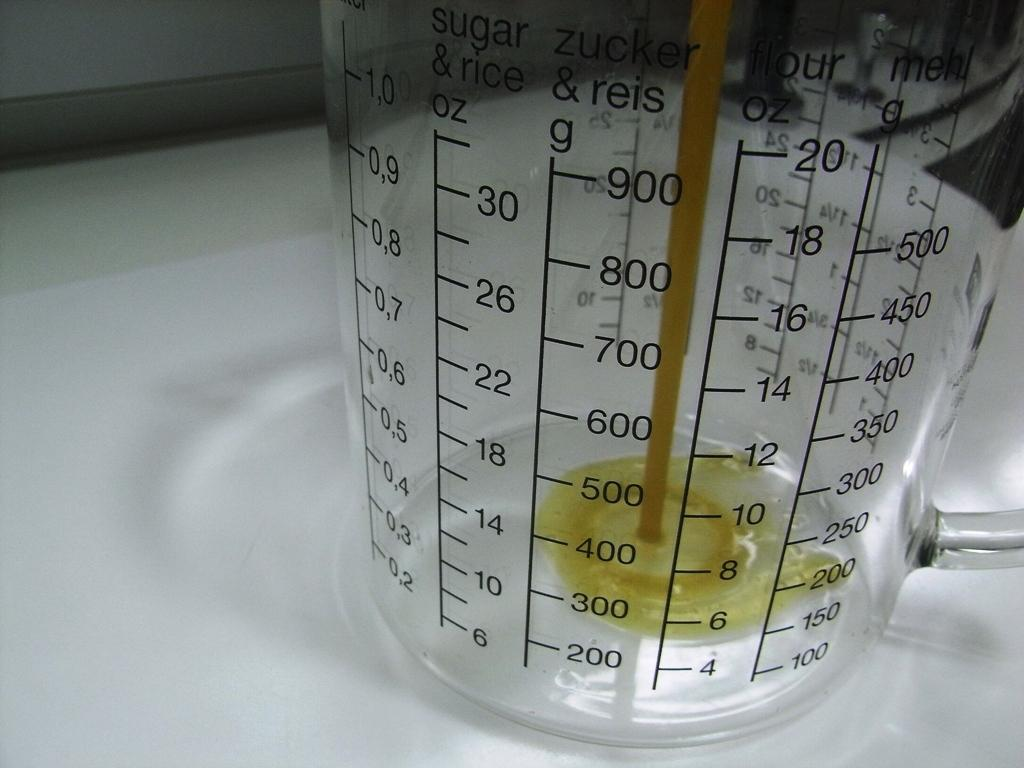<image>
Share a concise interpretation of the image provided. a glass beaker has measurements for sugar and rice on it 